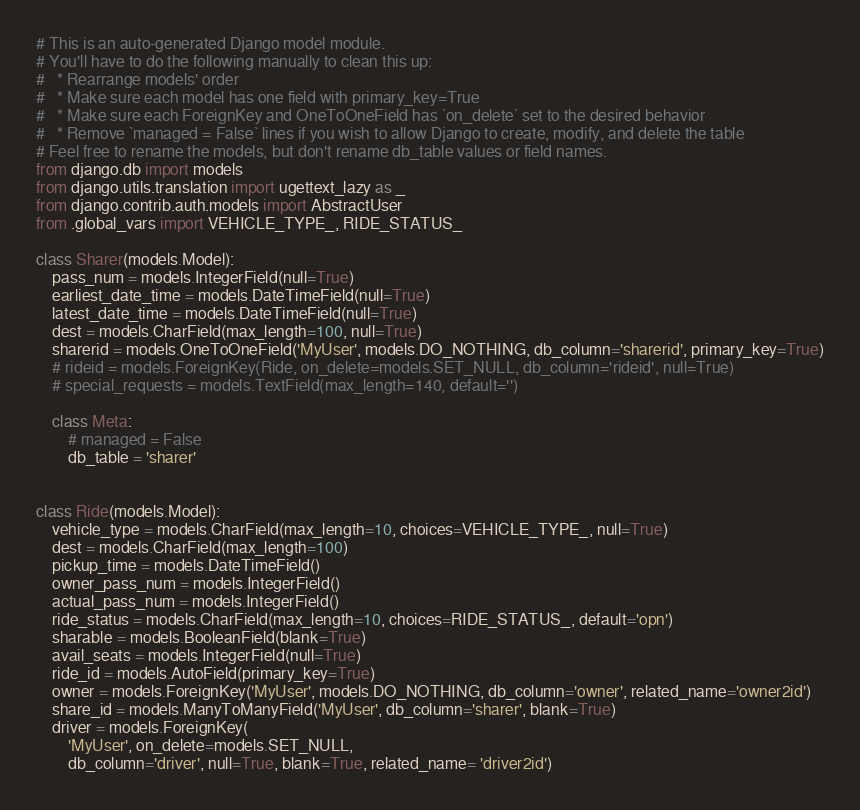Convert code to text. <code><loc_0><loc_0><loc_500><loc_500><_Python_># This is an auto-generated Django model module.
# You'll have to do the following manually to clean this up:
#   * Rearrange models' order
#   * Make sure each model has one field with primary_key=True
#   * Make sure each ForeignKey and OneToOneField has `on_delete` set to the desired behavior
#   * Remove `managed = False` lines if you wish to allow Django to create, modify, and delete the table
# Feel free to rename the models, but don't rename db_table values or field names.
from django.db import models
from django.utils.translation import ugettext_lazy as _
from django.contrib.auth.models import AbstractUser
from .global_vars import VEHICLE_TYPE_, RIDE_STATUS_

class Sharer(models.Model):
    pass_num = models.IntegerField(null=True)
    earliest_date_time = models.DateTimeField(null=True)
    latest_date_time = models.DateTimeField(null=True)
    dest = models.CharField(max_length=100, null=True)
    sharerid = models.OneToOneField('MyUser', models.DO_NOTHING, db_column='sharerid', primary_key=True)
    # rideid = models.ForeignKey(Ride, on_delete=models.SET_NULL, db_column='rideid', null=True)
    # special_requests = models.TextField(max_length=140, default='')

    class Meta:
        # managed = False
        db_table = 'sharer'


class Ride(models.Model):
    vehicle_type = models.CharField(max_length=10, choices=VEHICLE_TYPE_, null=True)
    dest = models.CharField(max_length=100)
    pickup_time = models.DateTimeField()
    owner_pass_num = models.IntegerField()
    actual_pass_num = models.IntegerField()
    ride_status = models.CharField(max_length=10, choices=RIDE_STATUS_, default='opn')
    sharable = models.BooleanField(blank=True)
    avail_seats = models.IntegerField(null=True)
    ride_id = models.AutoField(primary_key=True)
    owner = models.ForeignKey('MyUser', models.DO_NOTHING, db_column='owner', related_name='owner2id')
    share_id = models.ManyToManyField('MyUser', db_column='sharer', blank=True)
    driver = models.ForeignKey(
        'MyUser', on_delete=models.SET_NULL, 
        db_column='driver', null=True, blank=True, related_name= 'driver2id')</code> 